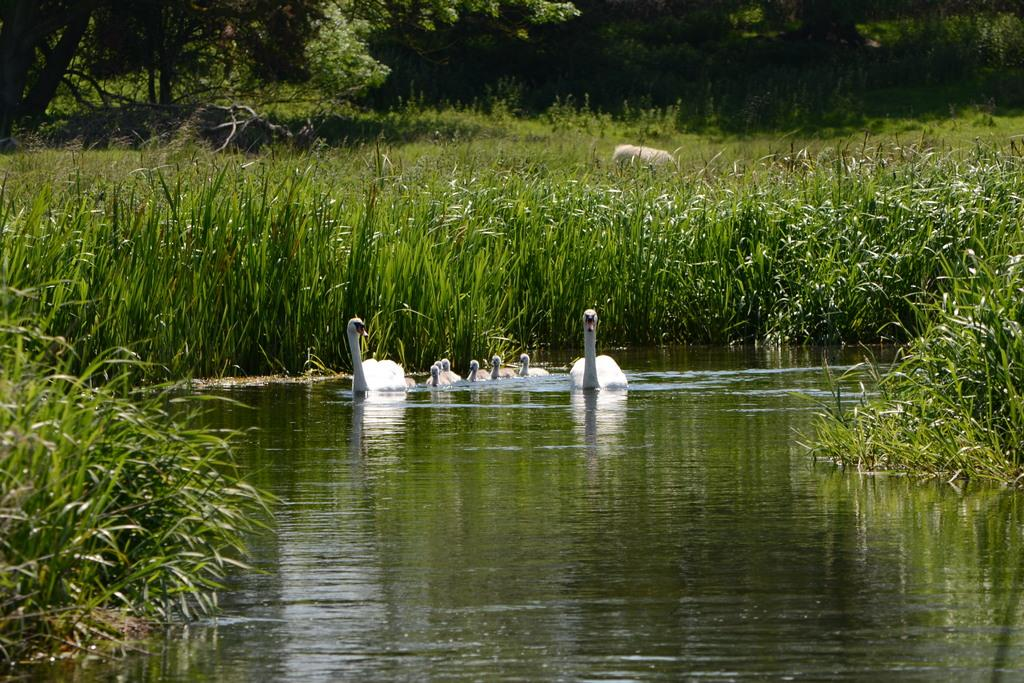What type of animals are in the water in the image? There are swans in the water in the image. What can be seen in the background of the image? Trees and plants are visible in the image. What type of dress is the swan wearing in the image? Swans do not wear dresses, as they are animals and not humans. 